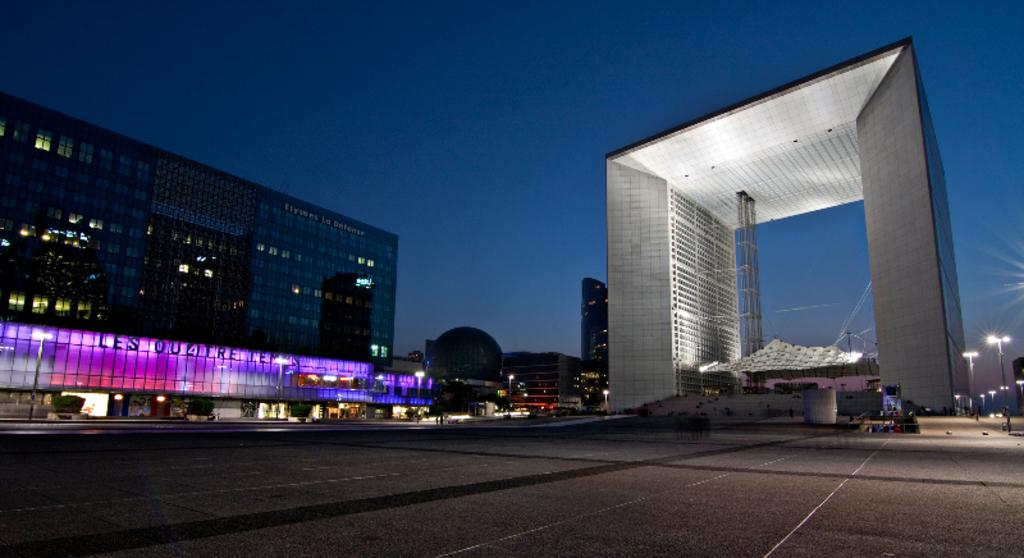What is the main feature of the image? There is a road in the image. What can be seen in the distance behind the road? There is a building and an architecture in the background of the image. What part of the natural environment is visible in the image? The sky is visible in the image. Can you see a rifle leaning against the building in the image? No, there is no rifle present in the image. Are there any nuts scattered on the road in the image? No, there are no nuts visible on the road in the image. 